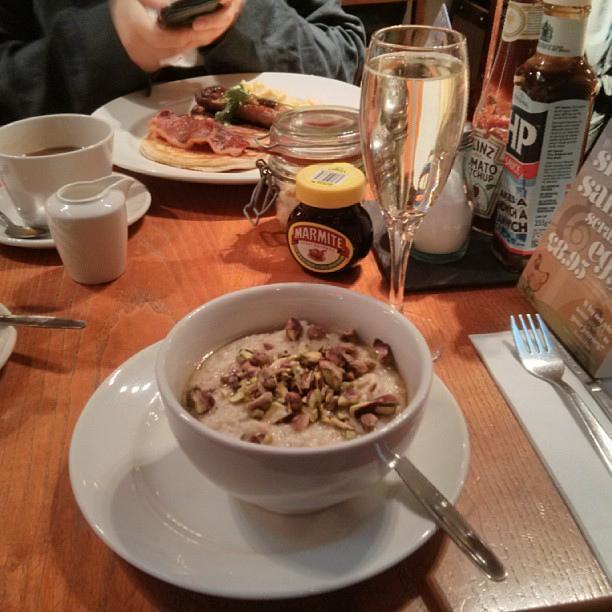The person that invented the item with the yellow lid was from what country?
Answer the question by selecting the correct answer among the 4 following choices and explain your choice with a short sentence. The answer should be formatted with the following format: `Answer: choice
Rationale: rationale.`
Options: Sweden, russia, thailand, germany. Answer: germany.
Rationale: The product was discovered as an edible item by a scientist from this country. 